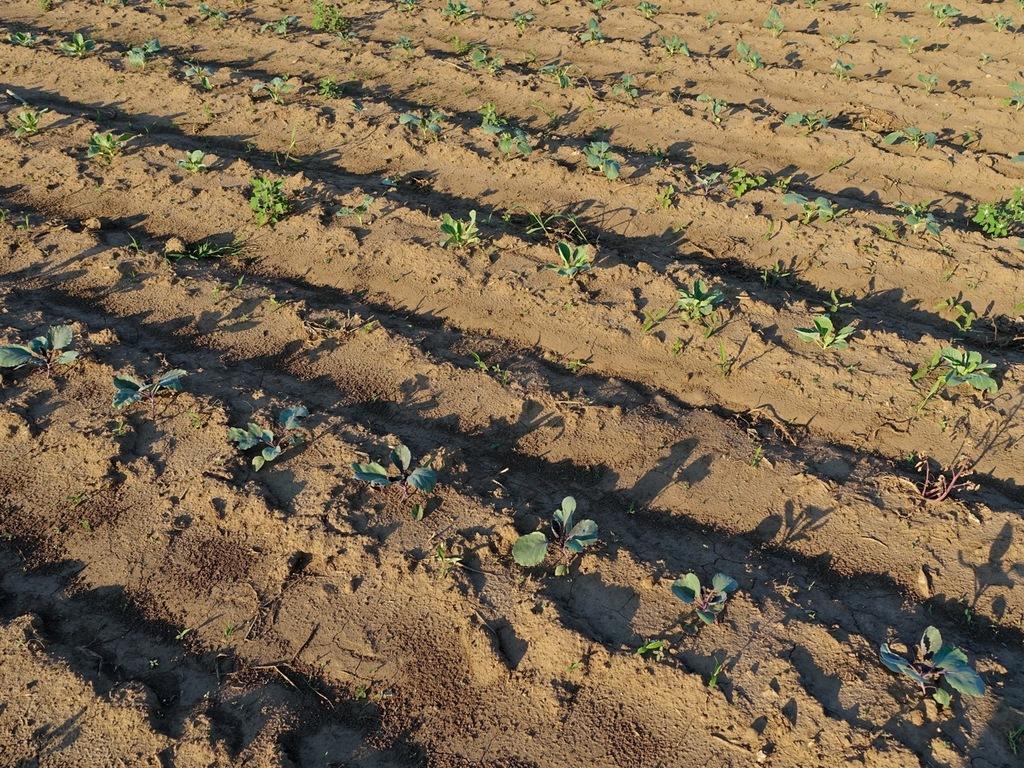Could you give a brief overview of what you see in this image? In this picture we can see small plants in the field. 